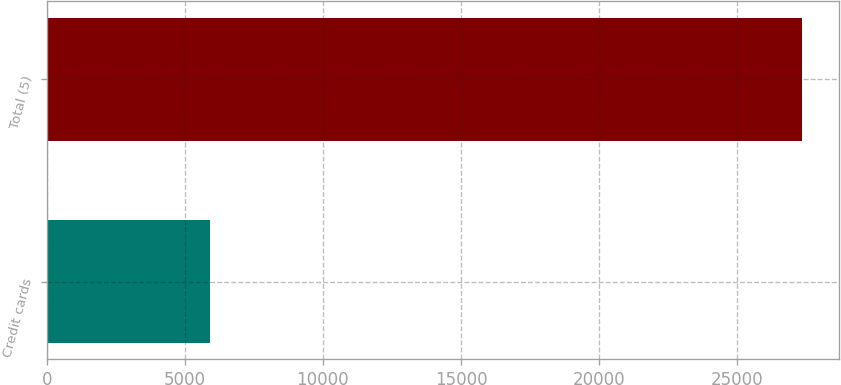<chart> <loc_0><loc_0><loc_500><loc_500><bar_chart><fcel>Credit cards<fcel>Total (5)<nl><fcel>5906<fcel>27328<nl></chart> 